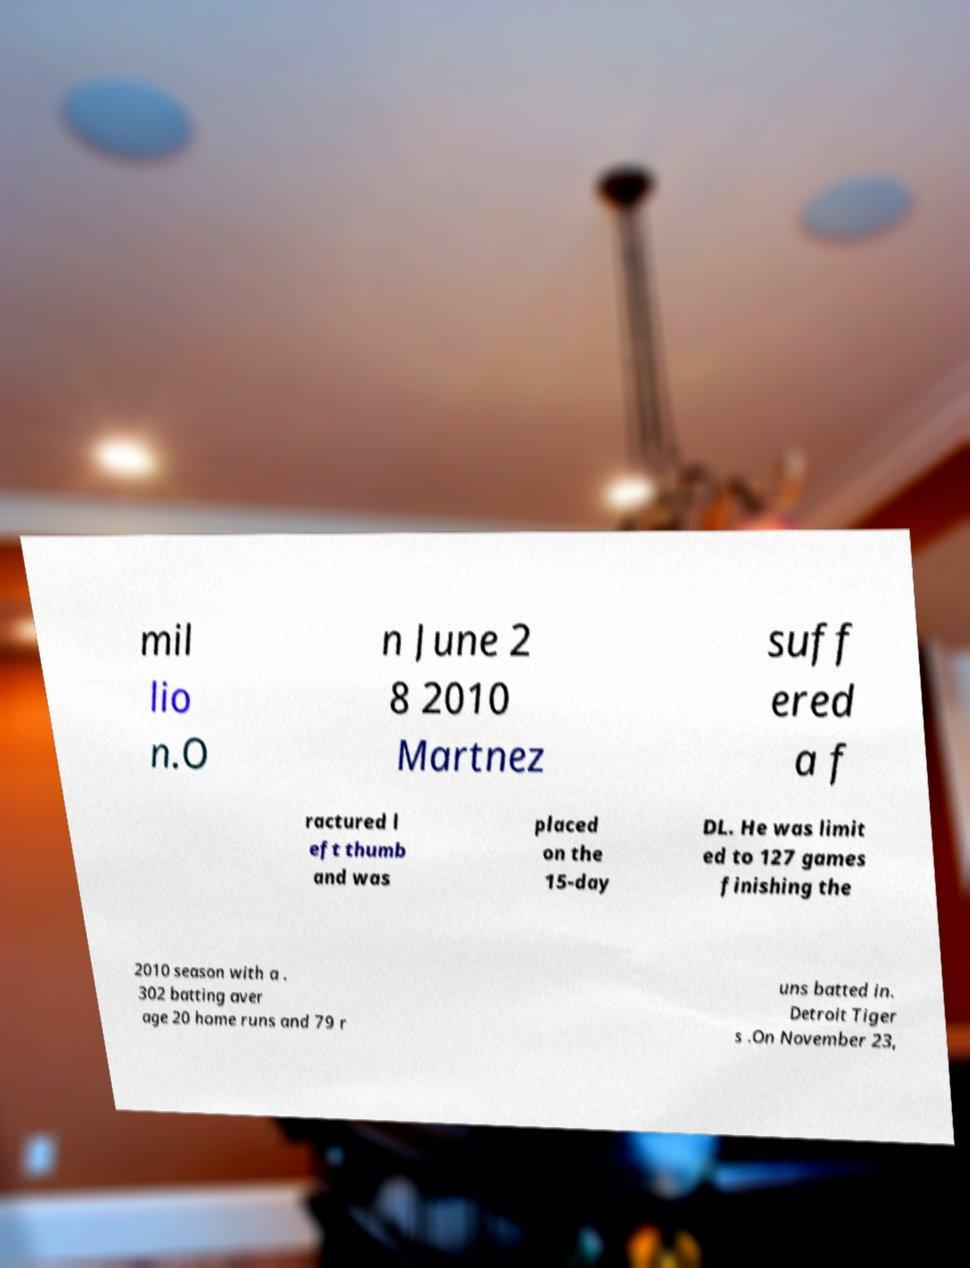Could you assist in decoding the text presented in this image and type it out clearly? mil lio n.O n June 2 8 2010 Martnez suff ered a f ractured l eft thumb and was placed on the 15-day DL. He was limit ed to 127 games finishing the 2010 season with a . 302 batting aver age 20 home runs and 79 r uns batted in. Detroit Tiger s .On November 23, 